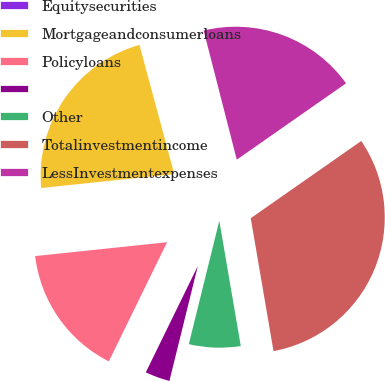Convert chart to OTSL. <chart><loc_0><loc_0><loc_500><loc_500><pie_chart><fcel>Equitysecurities<fcel>Mortgageandconsumerloans<fcel>Policyloans<fcel>Unnamed: 3<fcel>Other<fcel>Totalinvestmentincome<fcel>LessInvestmentexpenses<nl><fcel>0.2%<fcel>22.47%<fcel>16.1%<fcel>3.38%<fcel>6.56%<fcel>32.01%<fcel>19.29%<nl></chart> 